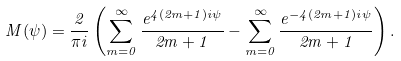<formula> <loc_0><loc_0><loc_500><loc_500>M ( \psi ) = \frac { 2 } { \pi i } \left ( \sum _ { m = 0 } ^ { \infty } \frac { e ^ { 4 ( 2 m + 1 ) i \psi } } { 2 m + 1 } - \sum _ { m = 0 } ^ { \infty } \frac { e ^ { - 4 ( 2 m + 1 ) i \psi } } { 2 m + 1 } \right ) .</formula> 